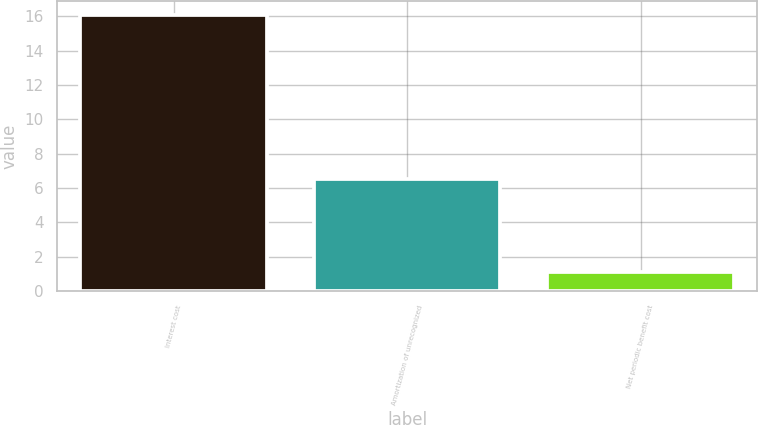Convert chart to OTSL. <chart><loc_0><loc_0><loc_500><loc_500><bar_chart><fcel>Interest cost<fcel>Amortization of unrecognized<fcel>Net periodic benefit cost<nl><fcel>16.1<fcel>6.5<fcel>1.1<nl></chart> 